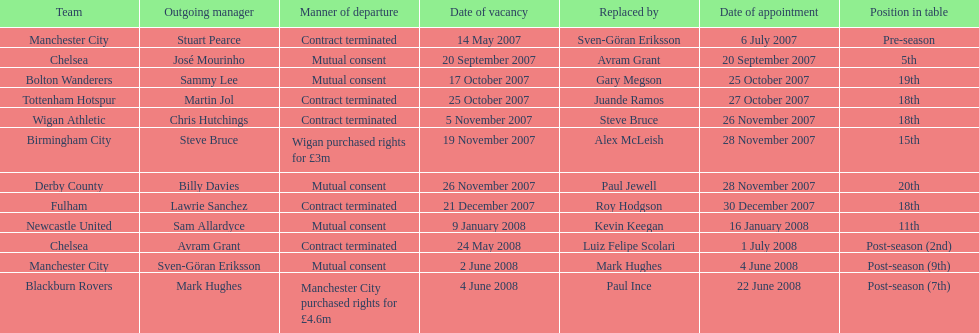What was the exclusive team to finish 5th referred to as? Chelsea. 